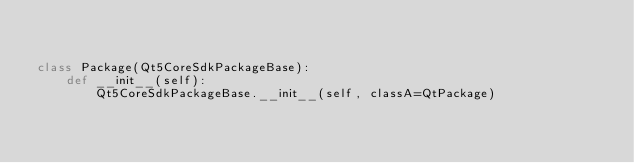Convert code to text. <code><loc_0><loc_0><loc_500><loc_500><_Python_>

class Package(Qt5CoreSdkPackageBase):
    def __init__(self):
        Qt5CoreSdkPackageBase.__init__(self, classA=QtPackage)
</code> 